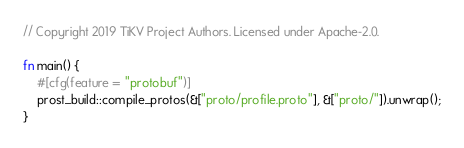Convert code to text. <code><loc_0><loc_0><loc_500><loc_500><_Rust_>// Copyright 2019 TiKV Project Authors. Licensed under Apache-2.0.

fn main() {
    #[cfg(feature = "protobuf")]
    prost_build::compile_protos(&["proto/profile.proto"], &["proto/"]).unwrap();
}
</code> 